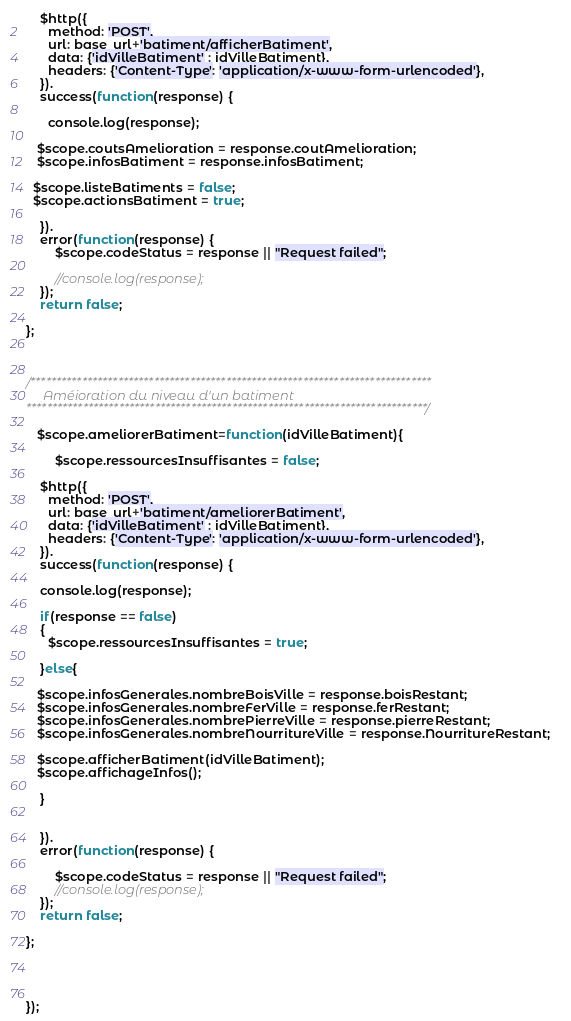Convert code to text. <code><loc_0><loc_0><loc_500><loc_500><_JavaScript_>
    $http({
      method: 'POST',
      url: base_url+'batiment/afficherBatiment',
      data: {'idVilleBatiment' : idVilleBatiment},
      headers: {'Content-Type': 'application/x-www-form-urlencoded'},
    }).
    success(function(response) {

      console.log(response);
     
   $scope.coutsAmelioration = response.coutAmelioration;
   $scope.infosBatiment = response.infosBatiment;  

  $scope.listeBatiments = false;
  $scope.actionsBatiment = true;

    }).
    error(function(response) {
        $scope.codeStatus = response || "Request failed";
        
        //console.log(response);
    });
    return false;

};
  


/******************************************************************************
     Améioration du niveau d'un batiment
******************************************************************************/

   $scope.ameliorerBatiment=function(idVilleBatiment){

        $scope.ressourcesInsuffisantes = false;

    $http({
      method: 'POST',
      url: base_url+'batiment/ameliorerBatiment',
      data: {'idVilleBatiment' : idVilleBatiment},
      headers: {'Content-Type': 'application/x-www-form-urlencoded'},
    }).
    success(function(response) {
     
    console.log(response);

    if(response == false)
    {
      $scope.ressourcesInsuffisantes = true;

    }else{

   $scope.infosGenerales.nombreBoisVille = response.boisRestant;
   $scope.infosGenerales.nombreFerVille = response.ferRestant;
   $scope.infosGenerales.nombrePierreVille = response.pierreRestant;
   $scope.infosGenerales.nombreNourritureVille = response.NourritureRestant;   

   $scope.afficherBatiment(idVilleBatiment);
   $scope.affichageInfos();

    }

        
    }).
    error(function(response) {

        $scope.codeStatus = response || "Request failed";
        //console.log(response);
    });
    return false;

};




});




</code> 